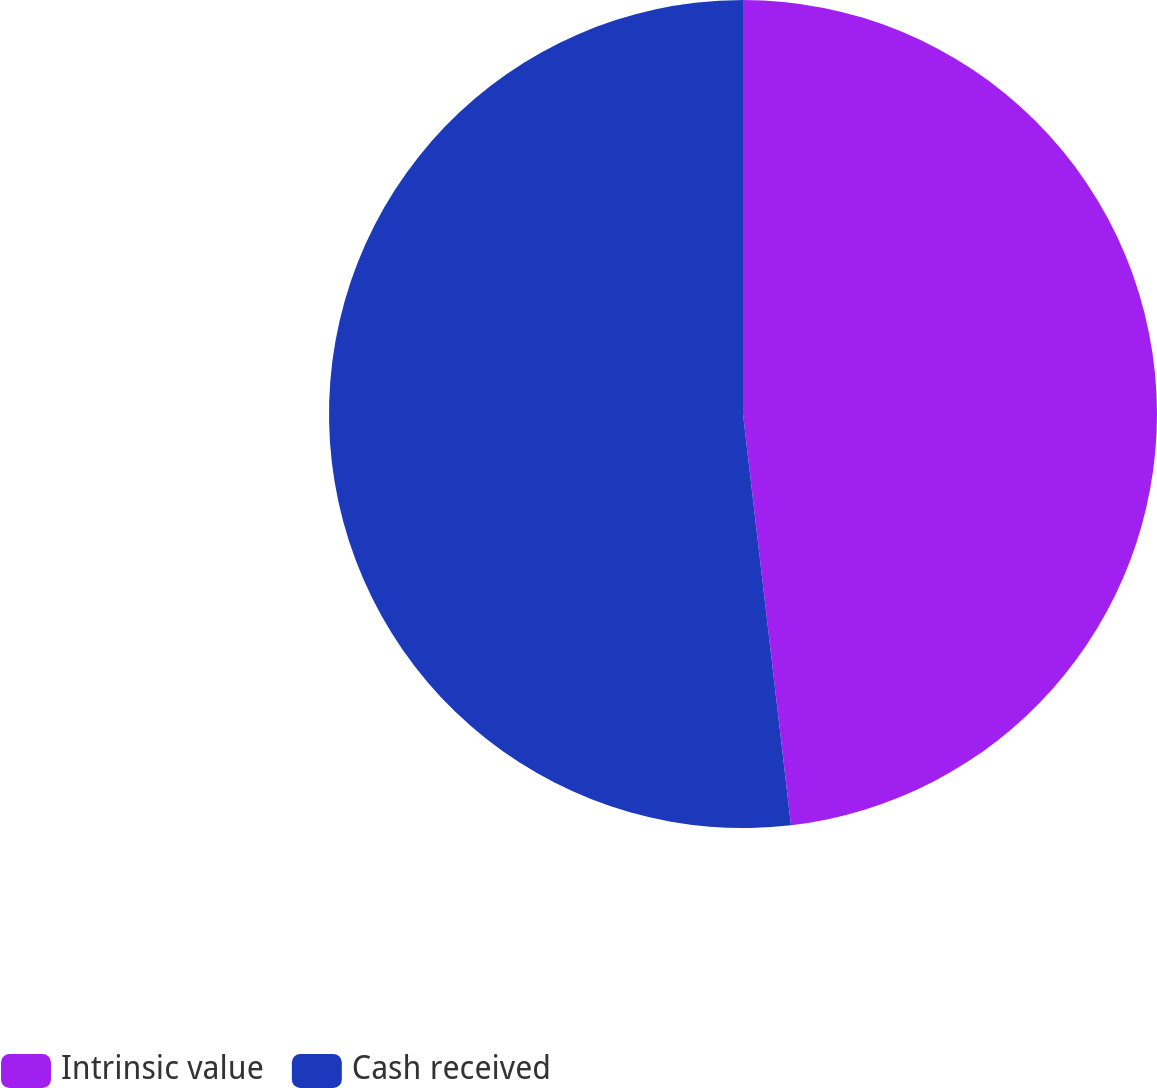Convert chart to OTSL. <chart><loc_0><loc_0><loc_500><loc_500><pie_chart><fcel>Intrinsic value<fcel>Cash received<nl><fcel>48.15%<fcel>51.85%<nl></chart> 